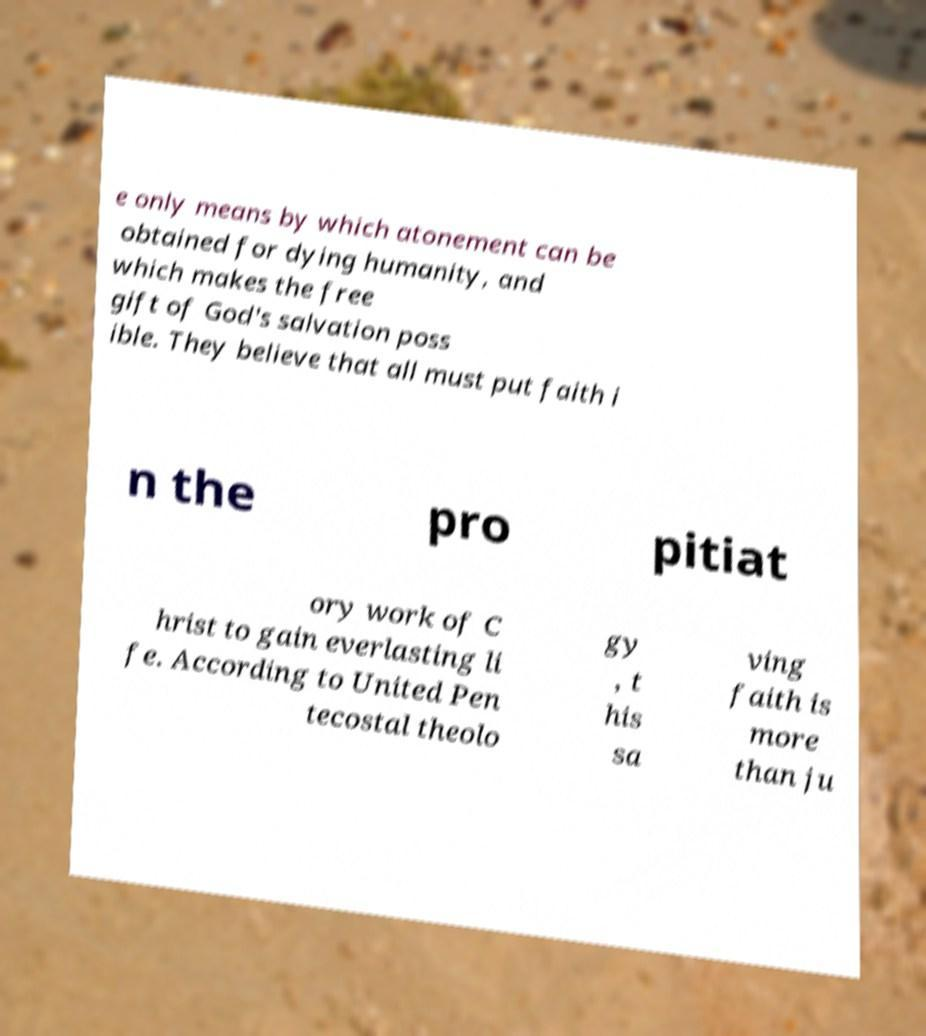Can you read and provide the text displayed in the image?This photo seems to have some interesting text. Can you extract and type it out for me? e only means by which atonement can be obtained for dying humanity, and which makes the free gift of God's salvation poss ible. They believe that all must put faith i n the pro pitiat ory work of C hrist to gain everlasting li fe. According to United Pen tecostal theolo gy , t his sa ving faith is more than ju 